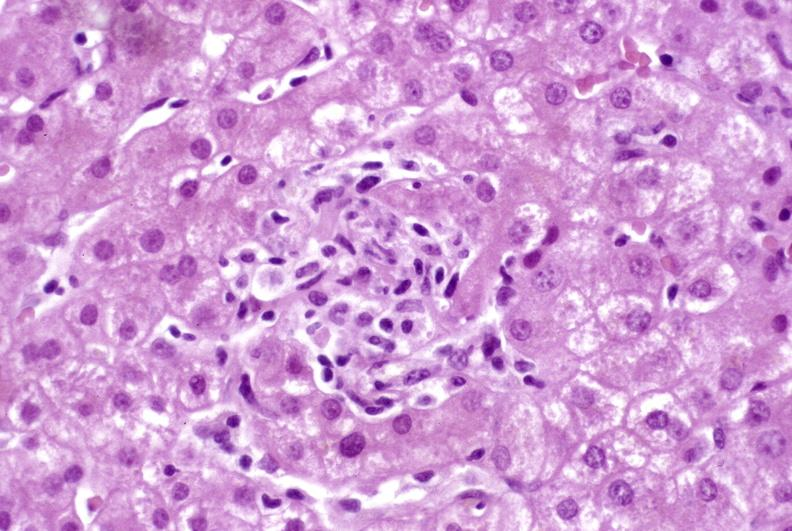s liver present?
Answer the question using a single word or phrase. Yes 